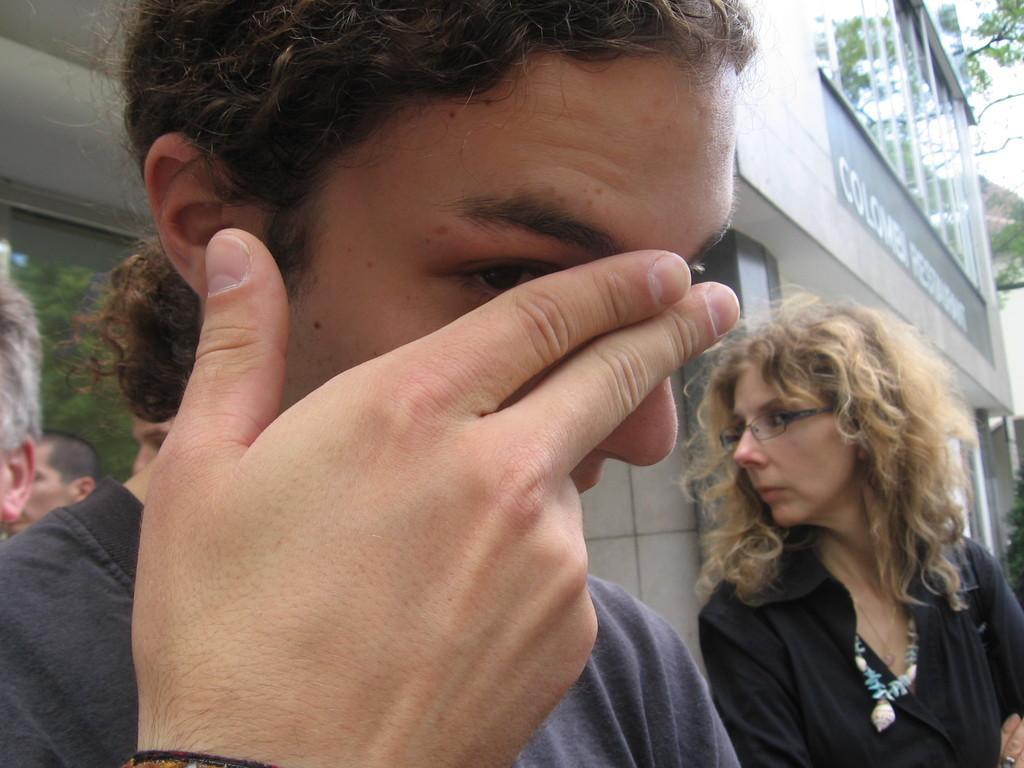How many people are in the image? There are people in the image, but the exact number is not specified. What is located behind the people in the image? There is a building behind the people in the image. What can be seen on the building? There is text visible on the building. What type of vegetation is present in the image? There are trees in the image. What part of the natural environment is visible in the image? The sky is visible in the image. What type of attraction can be smelled in the image? There is no indication of any attraction or smell in the image; it only features people, a building, trees, and the sky. 